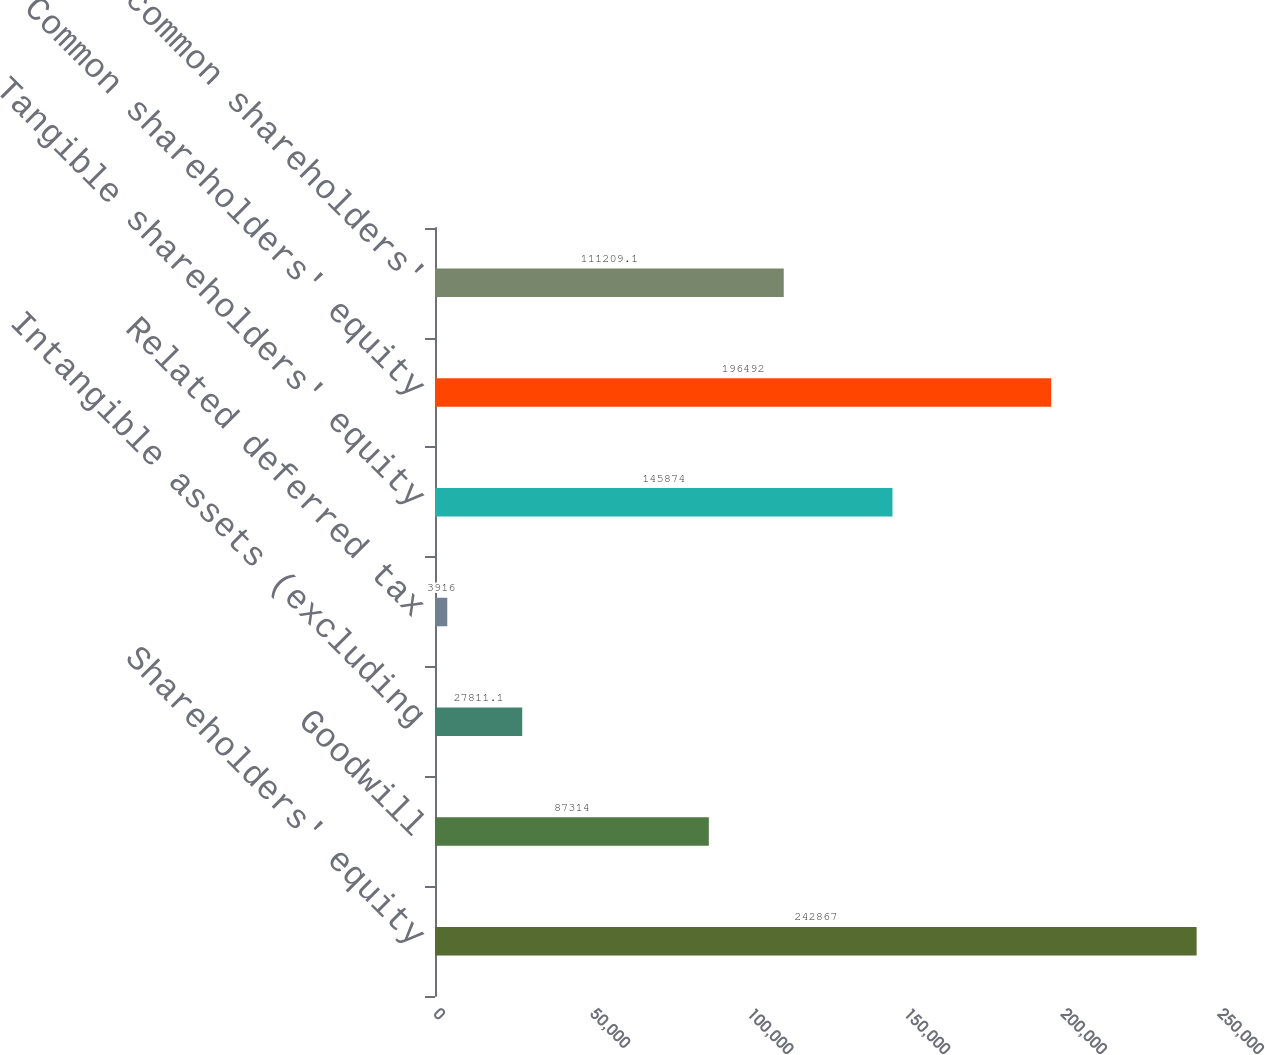<chart> <loc_0><loc_0><loc_500><loc_500><bar_chart><fcel>Shareholders' equity<fcel>Goodwill<fcel>Intangible assets (excluding<fcel>Related deferred tax<fcel>Tangible shareholders' equity<fcel>Common shareholders' equity<fcel>Tangible common shareholders'<nl><fcel>242867<fcel>87314<fcel>27811.1<fcel>3916<fcel>145874<fcel>196492<fcel>111209<nl></chart> 